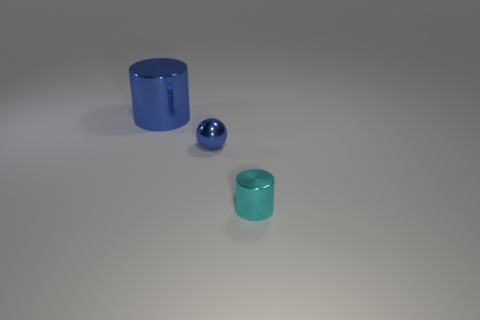There is a metal object that is the same color as the metallic sphere; what size is it?
Offer a very short reply. Large. How many objects are either gray balls or metallic cylinders in front of the blue ball?
Give a very brief answer. 1. There is a blue object that is on the right side of the large metallic cylinder; is its shape the same as the large shiny thing left of the tiny blue thing?
Your answer should be very brief. No. How many things are either large blue metal things or small cyan metal cylinders?
Your answer should be compact. 2. Are there any tiny purple rubber things?
Keep it short and to the point. No. Are there any other metallic things that have the same shape as the cyan shiny thing?
Provide a short and direct response. Yes. Are there the same number of metallic spheres to the left of the blue cylinder and large gray balls?
Your answer should be very brief. Yes. There is a blue object on the left side of the tiny thing that is to the left of the tiny cyan cylinder; what is it made of?
Offer a very short reply. Metal. The tiny blue metal thing is what shape?
Make the answer very short. Sphere. Are there an equal number of tiny cyan objects left of the ball and small metallic cylinders to the left of the cyan metal cylinder?
Provide a succinct answer. Yes. 